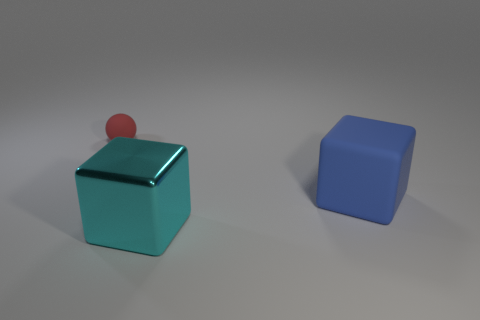There is a cube that is the same size as the blue rubber object; what is its color?
Make the answer very short. Cyan. Is there a big matte thing of the same color as the big rubber block?
Offer a very short reply. No. Are there fewer big blue objects that are behind the red matte thing than blue things that are on the right side of the big blue block?
Make the answer very short. No. There is a thing that is both to the right of the matte ball and behind the cyan cube; what material is it made of?
Keep it short and to the point. Rubber. Do the red thing and the large object that is behind the metal thing have the same shape?
Your answer should be compact. No. How many other objects are there of the same size as the red sphere?
Provide a succinct answer. 0. Are there more large rubber blocks than cyan matte cylinders?
Give a very brief answer. Yes. What number of rubber things are both left of the big blue cube and in front of the tiny red object?
Your answer should be compact. 0. There is a rubber object to the right of the object that is on the left side of the big cube that is in front of the blue thing; what shape is it?
Provide a succinct answer. Cube. Is there any other thing that is the same shape as the big blue thing?
Make the answer very short. Yes. 